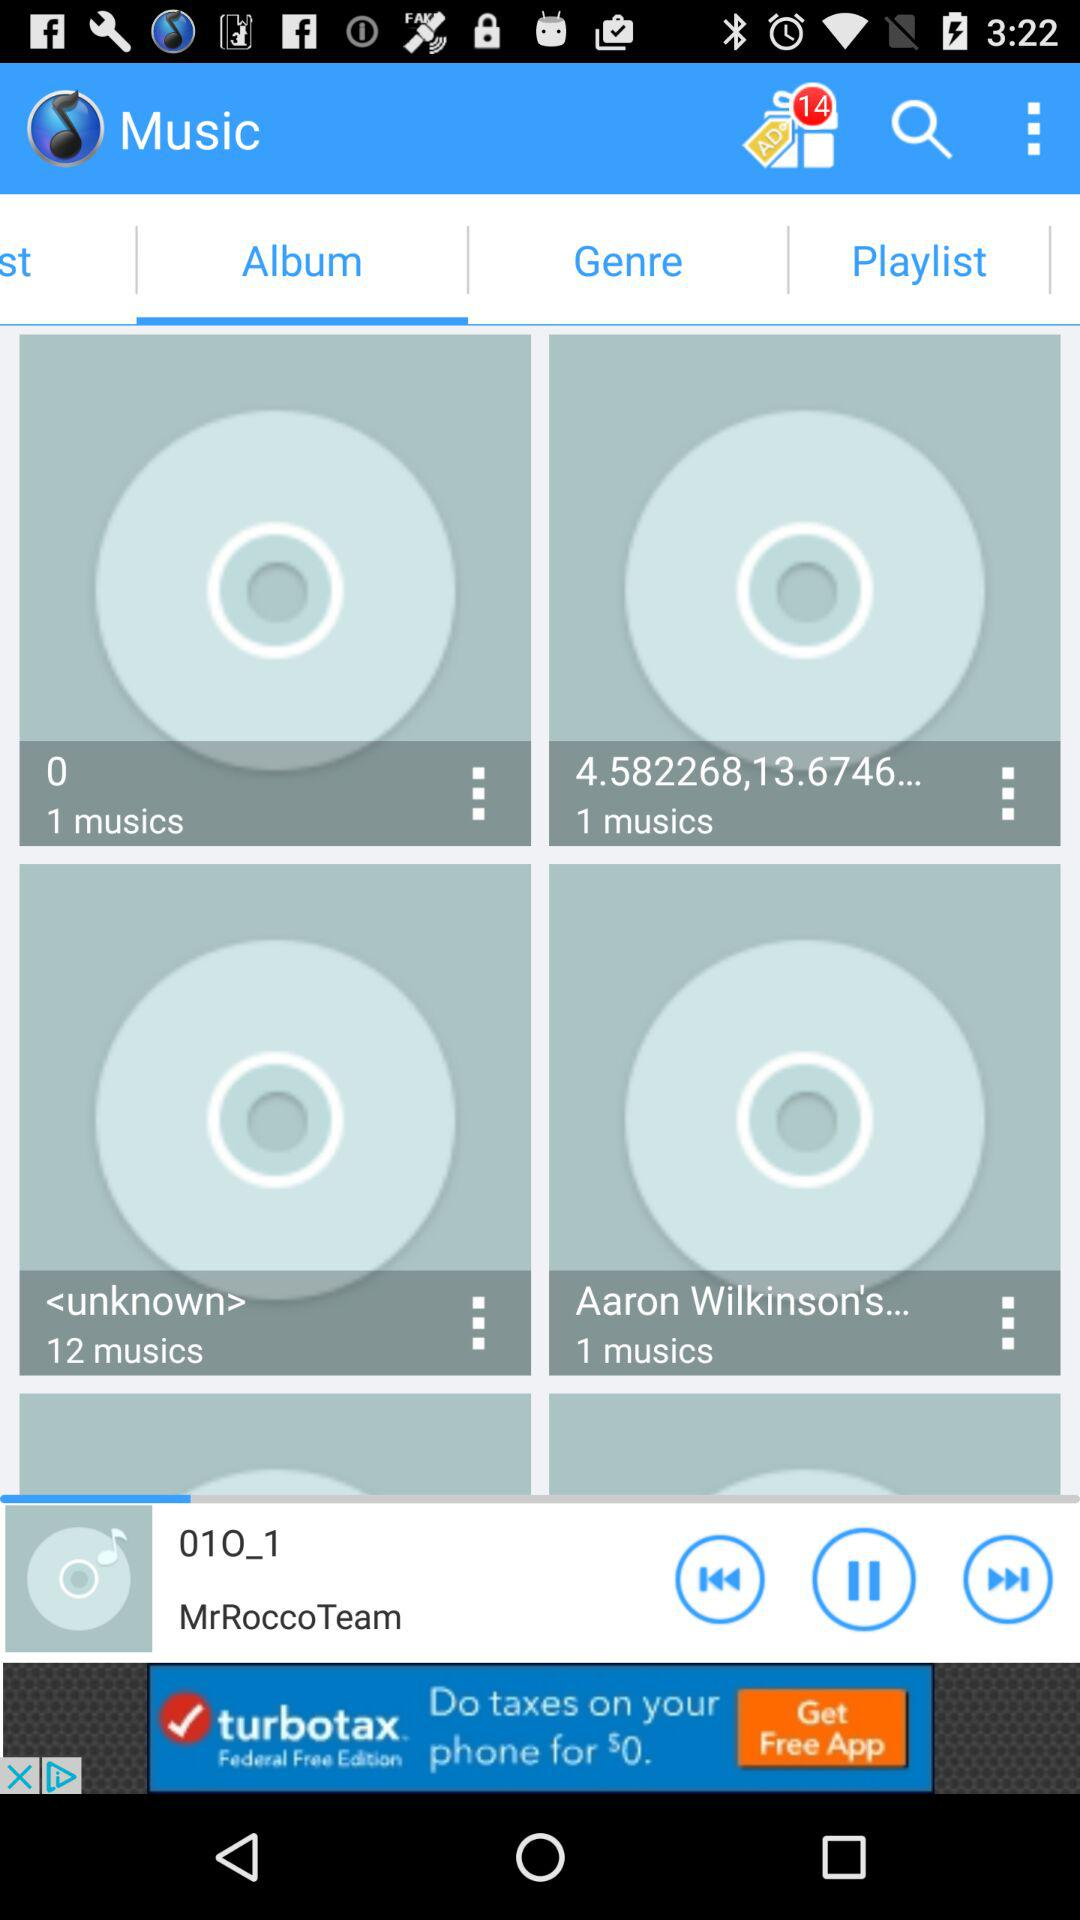Whose song is playing? The singer whose song is playing is MrRoccoTeam. 